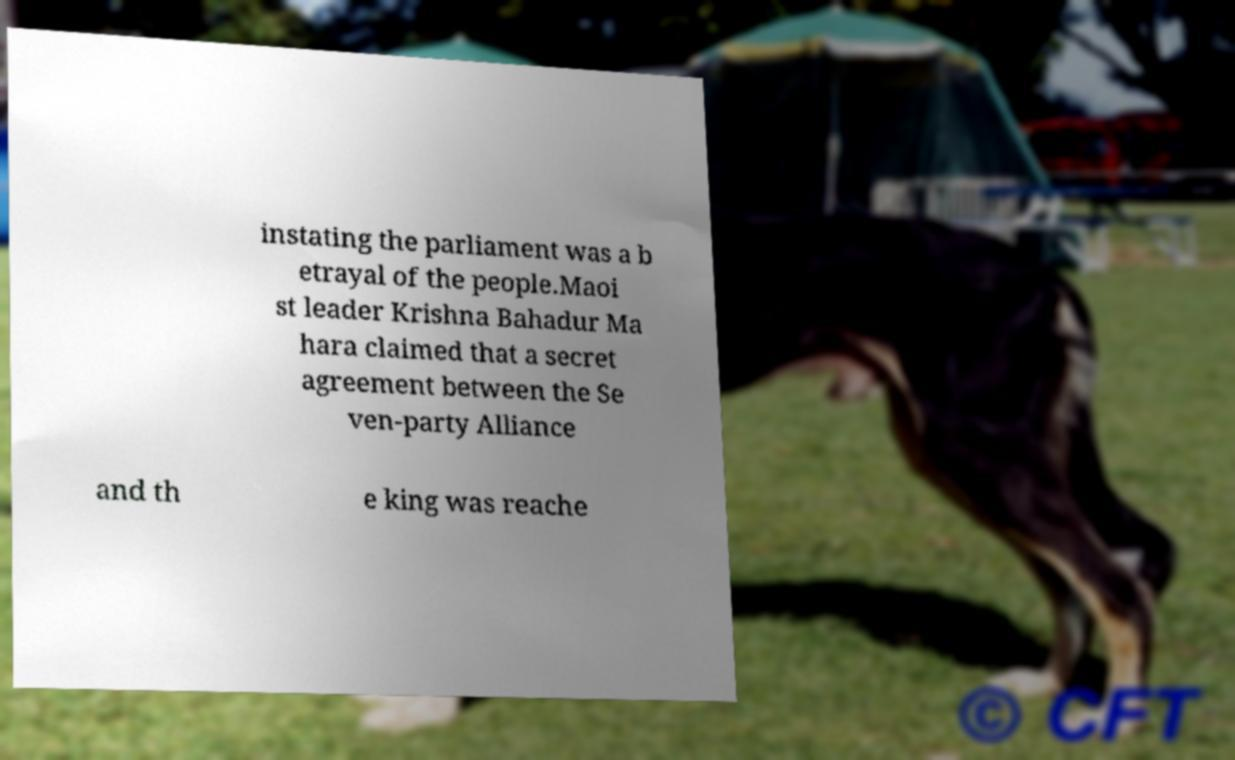I need the written content from this picture converted into text. Can you do that? instating the parliament was a b etrayal of the people.Maoi st leader Krishna Bahadur Ma hara claimed that a secret agreement between the Se ven-party Alliance and th e king was reache 